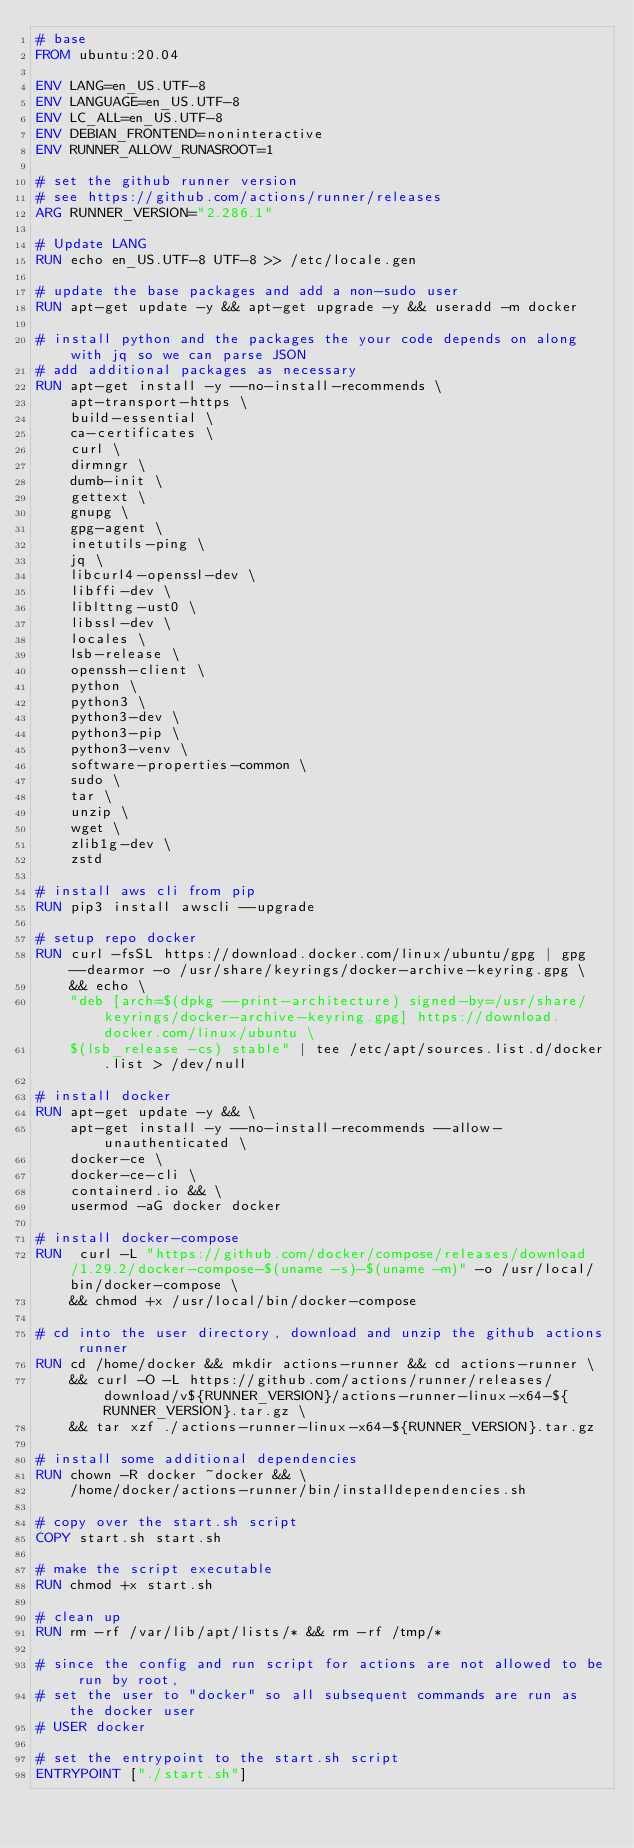<code> <loc_0><loc_0><loc_500><loc_500><_Dockerfile_># base
FROM ubuntu:20.04

ENV LANG=en_US.UTF-8
ENV LANGUAGE=en_US.UTF-8
ENV LC_ALL=en_US.UTF-8
ENV DEBIAN_FRONTEND=noninteractive
ENV RUNNER_ALLOW_RUNASROOT=1

# set the github runner version
# see https://github.com/actions/runner/releases
ARG RUNNER_VERSION="2.286.1"

# Update LANG
RUN echo en_US.UTF-8 UTF-8 >> /etc/locale.gen

# update the base packages and add a non-sudo user
RUN apt-get update -y && apt-get upgrade -y && useradd -m docker

# install python and the packages the your code depends on along with jq so we can parse JSON
# add additional packages as necessary
RUN apt-get install -y --no-install-recommends \
    apt-transport-https \
    build-essential \
    ca-certificates \
    curl \
    dirmngr \
    dumb-init \
    gettext \
    gnupg \
    gpg-agent \
    inetutils-ping \
    jq \
    libcurl4-openssl-dev \
    libffi-dev \
    liblttng-ust0 \
    libssl-dev \
    locales \
    lsb-release \
    openssh-client \
    python \
    python3 \
    python3-dev \
    python3-pip \
    python3-venv \
    software-properties-common \
    sudo \
    tar \
    unzip \
    wget \
    zlib1g-dev \
    zstd

# install aws cli from pip
RUN pip3 install awscli --upgrade

# setup repo docker
RUN curl -fsSL https://download.docker.com/linux/ubuntu/gpg | gpg --dearmor -o /usr/share/keyrings/docker-archive-keyring.gpg \
    && echo \
    "deb [arch=$(dpkg --print-architecture) signed-by=/usr/share/keyrings/docker-archive-keyring.gpg] https://download.docker.com/linux/ubuntu \
    $(lsb_release -cs) stable" | tee /etc/apt/sources.list.d/docker.list > /dev/null

# install docker
RUN apt-get update -y && \
    apt-get install -y --no-install-recommends --allow-unauthenticated \
    docker-ce \
    docker-ce-cli \
    containerd.io && \
    usermod -aG docker docker

# install docker-compose
RUN  curl -L "https://github.com/docker/compose/releases/download/1.29.2/docker-compose-$(uname -s)-$(uname -m)" -o /usr/local/bin/docker-compose \
    && chmod +x /usr/local/bin/docker-compose

# cd into the user directory, download and unzip the github actions runner
RUN cd /home/docker && mkdir actions-runner && cd actions-runner \
    && curl -O -L https://github.com/actions/runner/releases/download/v${RUNNER_VERSION}/actions-runner-linux-x64-${RUNNER_VERSION}.tar.gz \
    && tar xzf ./actions-runner-linux-x64-${RUNNER_VERSION}.tar.gz

# install some additional dependencies
RUN chown -R docker ~docker && \
    /home/docker/actions-runner/bin/installdependencies.sh

# copy over the start.sh script
COPY start.sh start.sh

# make the script executable
RUN chmod +x start.sh

# clean up
RUN rm -rf /var/lib/apt/lists/* && rm -rf /tmp/*

# since the config and run script for actions are not allowed to be run by root,
# set the user to "docker" so all subsequent commands are run as the docker user
# USER docker

# set the entrypoint to the start.sh script
ENTRYPOINT ["./start.sh"]</code> 